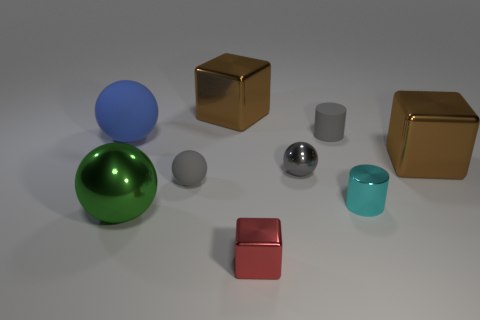Which objects are reflective, and what might their surfaces indicate about the material they are made of? In the image, the large green sphere, the small shiny silver cylinder, and the small gray sphere exhibit reflective surfaces, suggesting they are made of materials like polished metal or glossy plastic. These materials are often used for their reflective properties, which make objects stand out due to their eye-catching sheen.  Could you tell me more about how the lighting affects the appearance of these objects? Certainly. The lighting in the image creates highlights and shadows that accentuate the shapes and textures of the objects. The reflective materials, like the large green sphere and the small shiny cylinder, have pronounced highlights that outline their curvature, while the matte objects, such as the cyan cylinder and the brown cube, display more diffused and softer shadows, emphasizing their solidity and volume. 